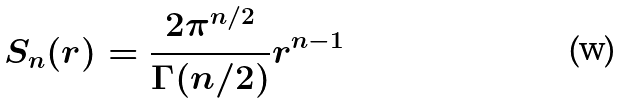Convert formula to latex. <formula><loc_0><loc_0><loc_500><loc_500>S _ { n } ( r ) = \frac { 2 \pi ^ { n / 2 } } { \Gamma ( n / 2 ) } r ^ { n - 1 }</formula> 